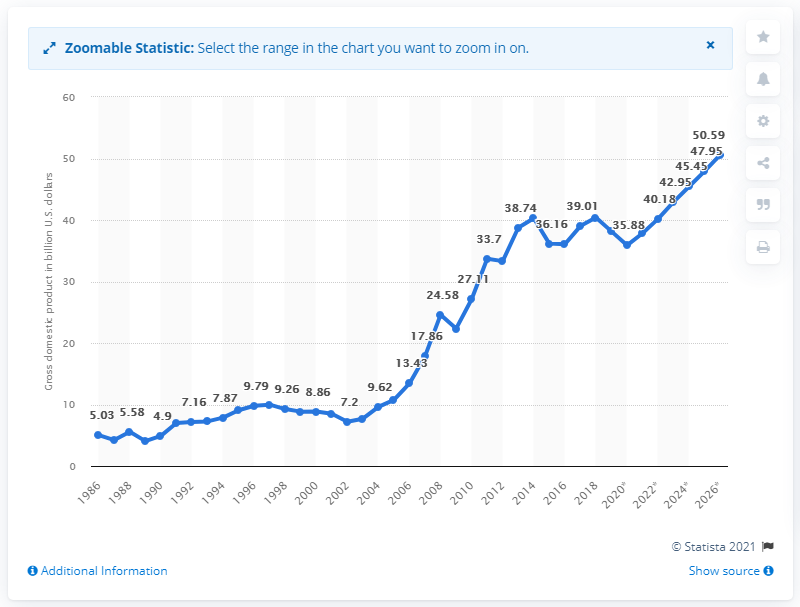Indicate a few pertinent items in this graphic. In 2019, Paraguay's Gross Domestic Product (GDP) was 37.84. 